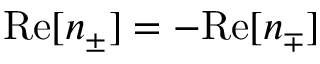<formula> <loc_0><loc_0><loc_500><loc_500>R e [ n _ { \pm } ] = - R e [ n _ { \mp } ]</formula> 